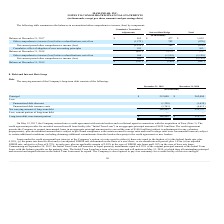According to Maxlinear's financial document, What was the Net carrying amount of long-term debt in 2019? According to the financial document, 206,909 (in thousands). The relevant text states: "Net carrying amount of long-term debt 206,909 255,757..." Also, What was the Net carrying amount of long-term debt in 2018? According to the financial document, 255,757 (in thousands). The relevant text states: "Net carrying amount of long-term debt 206,909 255,757..." Also, What was the principal amount in 2019 and 2018 respectively? The document shows two values: $212,000 and $262,000 (in thousands). From the document: "Principal $ 212,000 $ 262,000 Principal $ 212,000 $ 262,000..." Also, can you calculate: What was the change in the Principal from 2018 to 2019? Based on the calculation: 212,000 - 262,000, the result is -50000 (in thousands). This is based on the information: "Principal $ 212,000 $ 262,000 Principal $ 212,000 $ 262,000..." The key data points involved are: 212,000, 262,000. Also, can you calculate: What is the average Unamortized debt discount for 2018 and 2019? To answer this question, I need to perform calculations using the financial data. The calculation is: -(1,328 + 1,630) / 2, which equals -1479 (in thousands). This is based on the information: "Unamortized debt discount (1,328) (1,630) Unamortized debt discount (1,328) (1,630)..." The key data points involved are: 1,328, 1,630. Additionally, In which year was Net carrying amount of long-term debt less than 210,000 thousands? According to the financial document, 2019. The relevant text states: "December 31, 2019 December 31, 2018..." 